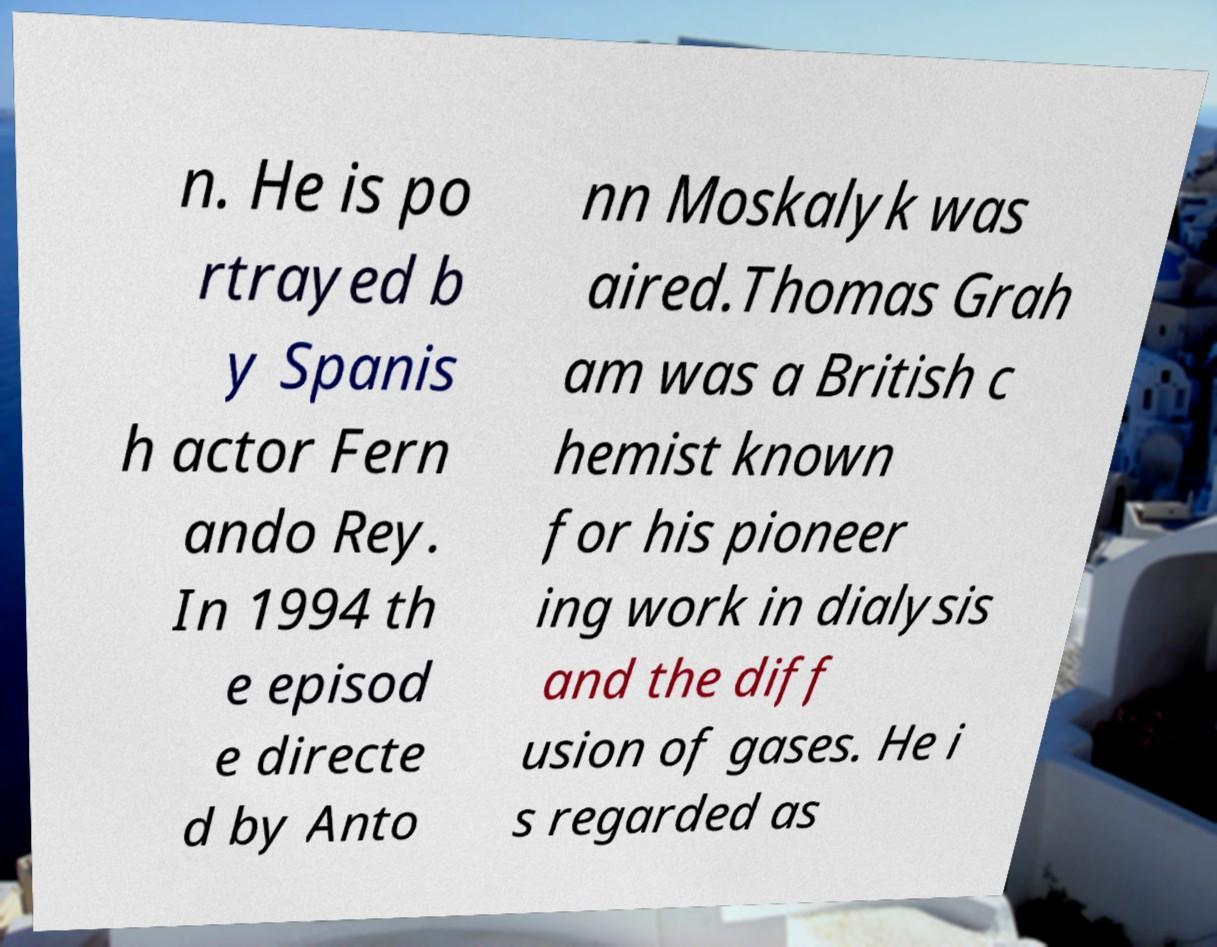For documentation purposes, I need the text within this image transcribed. Could you provide that? n. He is po rtrayed b y Spanis h actor Fern ando Rey. In 1994 th e episod e directe d by Anto nn Moskalyk was aired.Thomas Grah am was a British c hemist known for his pioneer ing work in dialysis and the diff usion of gases. He i s regarded as 